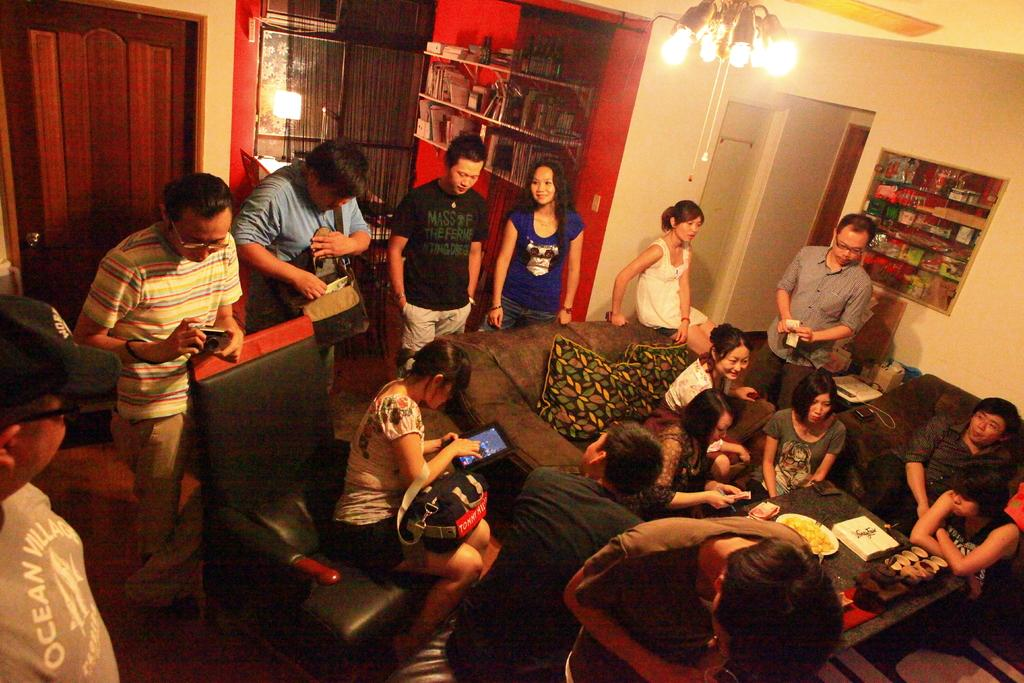How many people are in the room? There are people in the room, but the exact number is not specified. What are some of the people in the room doing? Some people are sitting on the sofa. What can be seen in the background of the room? There is a shelf in the background. What is visible at the top of the picture? Lights are visible at the top of the picture. What type of brain is visible on the shelf in the image? There is no brain visible on the shelf in the image. How much milk is being consumed by the people sitting on the sofa in the image? There is no mention of milk or any food or drink being consumed in the image. 